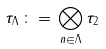<formula> <loc_0><loc_0><loc_500><loc_500>\tau _ { \Lambda } \, \colon = \, \bigotimes _ { n \in \Lambda } \tau _ { 2 }</formula> 